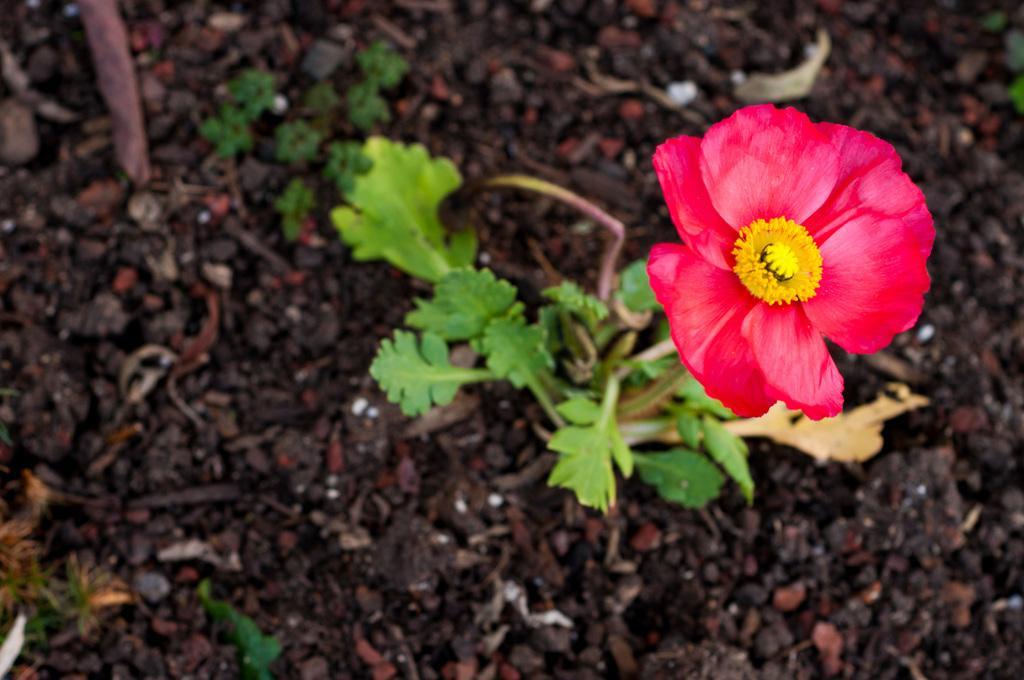Can you describe this image briefly? In this image we can see few plants. There is a flower to the plant. 